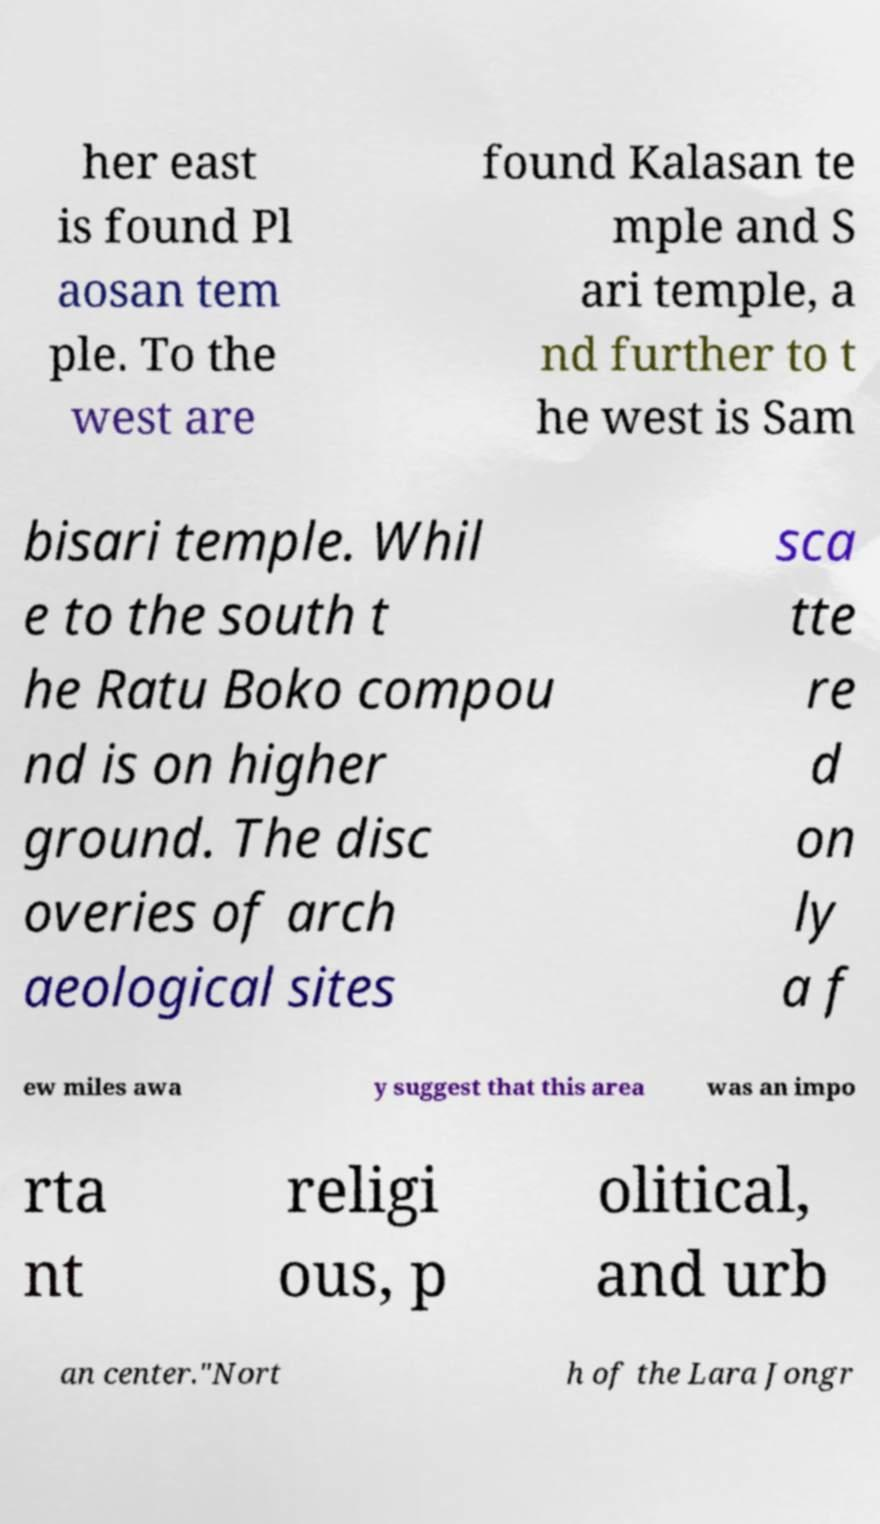There's text embedded in this image that I need extracted. Can you transcribe it verbatim? her east is found Pl aosan tem ple. To the west are found Kalasan te mple and S ari temple, a nd further to t he west is Sam bisari temple. Whil e to the south t he Ratu Boko compou nd is on higher ground. The disc overies of arch aeological sites sca tte re d on ly a f ew miles awa y suggest that this area was an impo rta nt religi ous, p olitical, and urb an center."Nort h of the Lara Jongr 